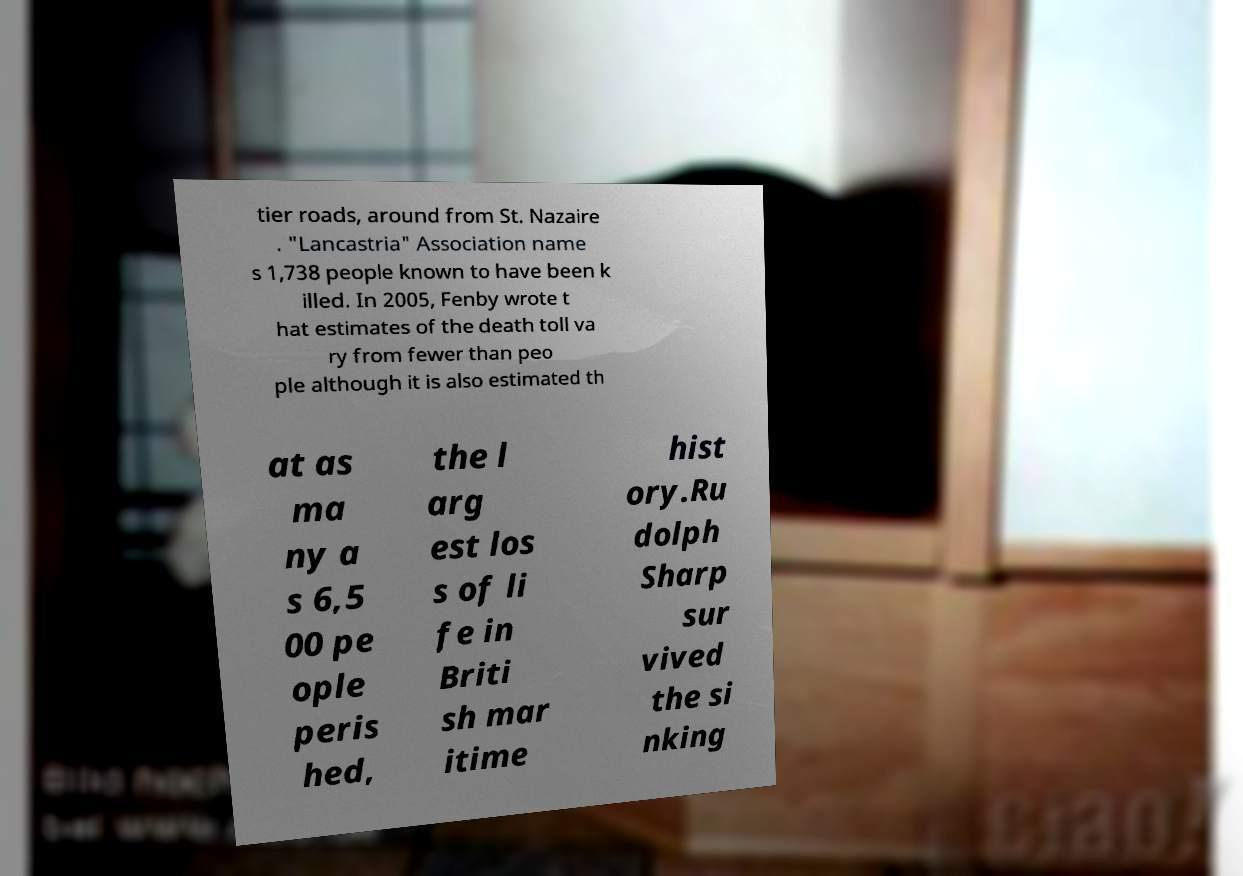What messages or text are displayed in this image? I need them in a readable, typed format. tier roads, around from St. Nazaire . "Lancastria" Association name s 1,738 people known to have been k illed. In 2005, Fenby wrote t hat estimates of the death toll va ry from fewer than peo ple although it is also estimated th at as ma ny a s 6,5 00 pe ople peris hed, the l arg est los s of li fe in Briti sh mar itime hist ory.Ru dolph Sharp sur vived the si nking 